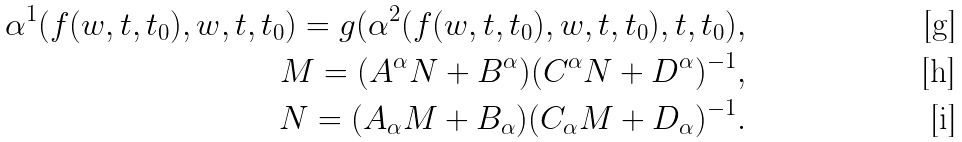<formula> <loc_0><loc_0><loc_500><loc_500>\alpha ^ { 1 } ( f ( w , t , t _ { 0 } ) , w , t , t _ { 0 } ) = g ( \alpha ^ { 2 } ( f ( w , t , t _ { 0 } ) , w , t , t _ { 0 } ) , t , t _ { 0 } ) , \\ M = ( A ^ { \alpha } N + B ^ { \alpha } ) ( C ^ { \alpha } N + D ^ { \alpha } ) ^ { - 1 } , \\ N = ( A _ { \alpha } M + B _ { \alpha } ) ( C _ { \alpha } M + D _ { \alpha } ) ^ { - 1 } .</formula> 